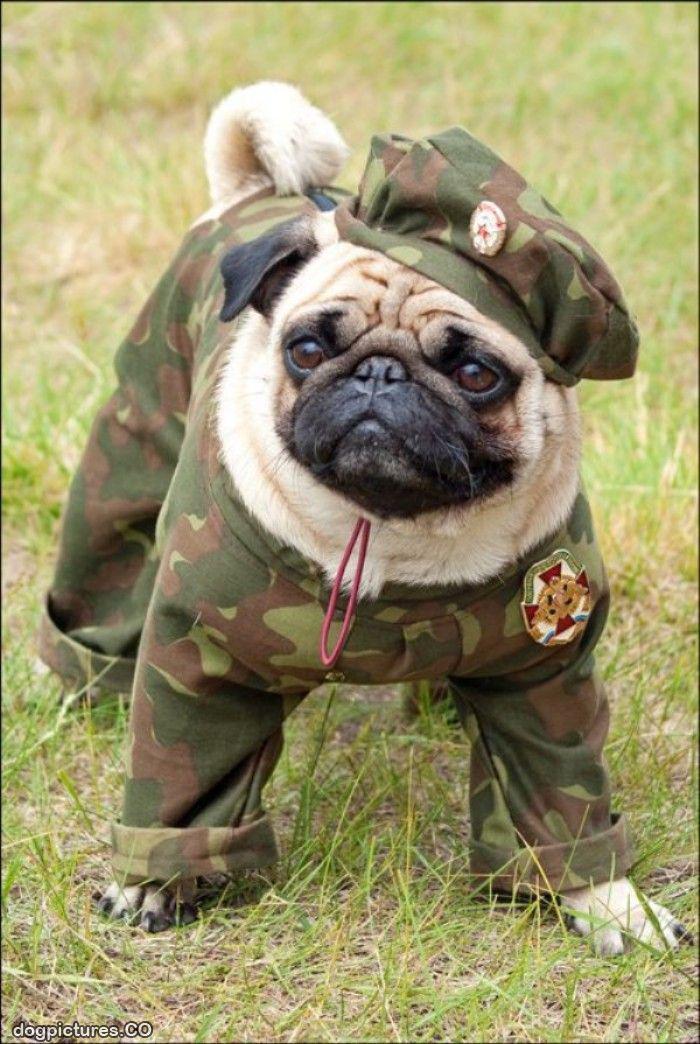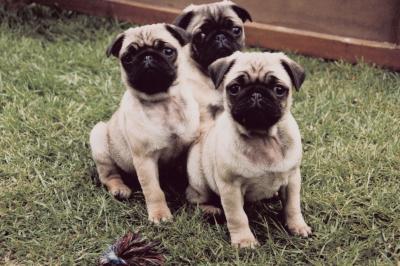The first image is the image on the left, the second image is the image on the right. Analyze the images presented: Is the assertion "There is at least three dogs." valid? Answer yes or no. Yes. The first image is the image on the left, the second image is the image on the right. Examine the images to the left and right. Is the description "Each image contains one pug wearing an outfit, including the letfthand dog wearing a grayish and yellow outift, and the righthand dog in formal human-like attire." accurate? Answer yes or no. No. 